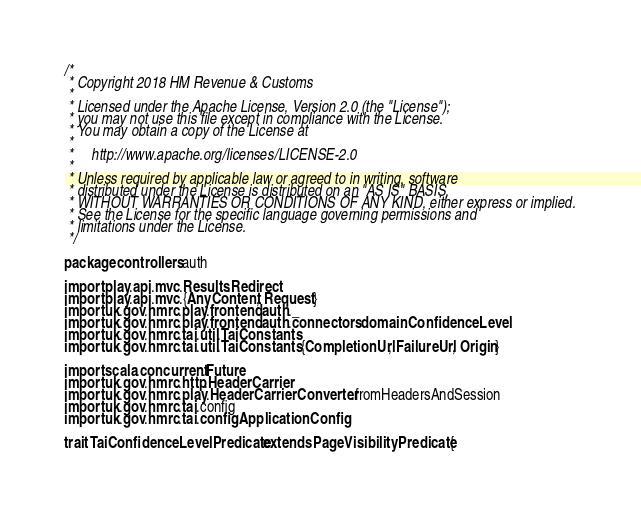<code> <loc_0><loc_0><loc_500><loc_500><_Scala_>/*
 * Copyright 2018 HM Revenue & Customs
 *
 * Licensed under the Apache License, Version 2.0 (the "License");
 * you may not use this file except in compliance with the License.
 * You may obtain a copy of the License at
 *
 *     http://www.apache.org/licenses/LICENSE-2.0
 *
 * Unless required by applicable law or agreed to in writing, software
 * distributed under the License is distributed on an "AS IS" BASIS,
 * WITHOUT WARRANTIES OR CONDITIONS OF ANY KIND, either express or implied.
 * See the License for the specific language governing permissions and
 * limitations under the License.
 */

package controllers.auth

import play.api.mvc.Results.Redirect
import play.api.mvc.{AnyContent, Request}
import uk.gov.hmrc.play.frontend.auth._
import uk.gov.hmrc.play.frontend.auth.connectors.domain.ConfidenceLevel
import uk.gov.hmrc.tai.util.TaiConstants
import uk.gov.hmrc.tai.util.TaiConstants.{CompletionUrl, FailureUrl, Origin}

import scala.concurrent.Future
import uk.gov.hmrc.http.HeaderCarrier
import uk.gov.hmrc.play.HeaderCarrierConverter.fromHeadersAndSession
import uk.gov.hmrc.tai.config
import uk.gov.hmrc.tai.config.ApplicationConfig

trait TaiConfidenceLevelPredicate extends PageVisibilityPredicate {
</code> 